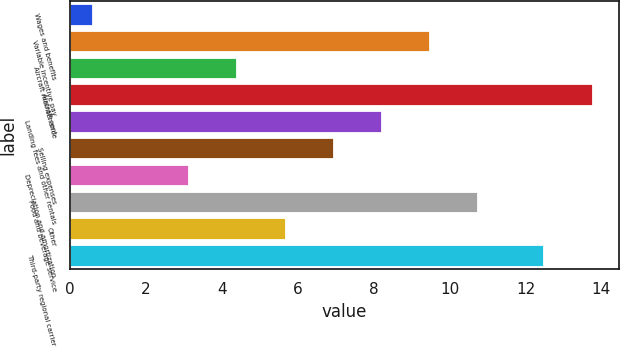<chart> <loc_0><loc_0><loc_500><loc_500><bar_chart><fcel>Wages and benefits<fcel>Variable incentive pay<fcel>Aircraft maintenance<fcel>Aircraft rent<fcel>Landing fees and other rentals<fcel>Selling expenses<fcel>Depreciation and amortization<fcel>Food and beverage service<fcel>Other<fcel>Third-party regional carrier<nl><fcel>0.6<fcel>9.49<fcel>4.41<fcel>13.77<fcel>8.22<fcel>6.95<fcel>3.14<fcel>10.76<fcel>5.68<fcel>12.5<nl></chart> 